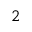<formula> <loc_0><loc_0><loc_500><loc_500>^ { 2 }</formula> 